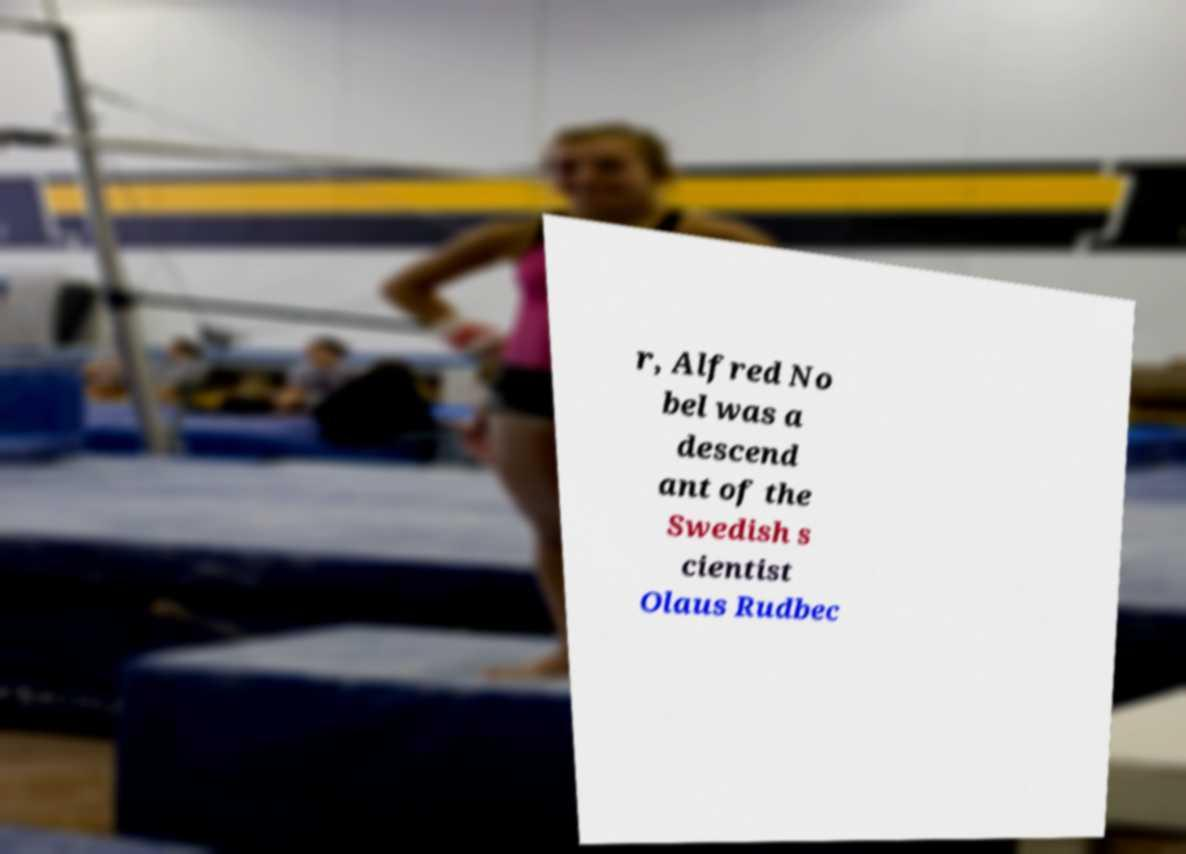Can you read and provide the text displayed in the image?This photo seems to have some interesting text. Can you extract and type it out for me? r, Alfred No bel was a descend ant of the Swedish s cientist Olaus Rudbec 